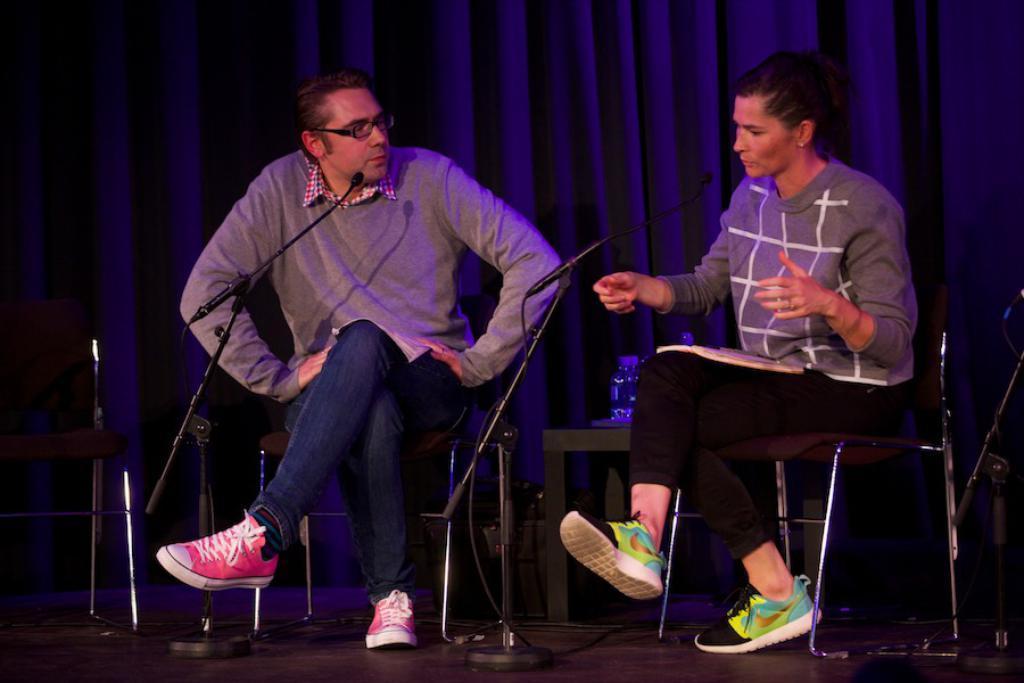Describe this image in one or two sentences. There are two people sitting on chairs and holding books and we can see microphones with stands and objects on the table. We can see bag on the floor. In the background we can see curtains. 